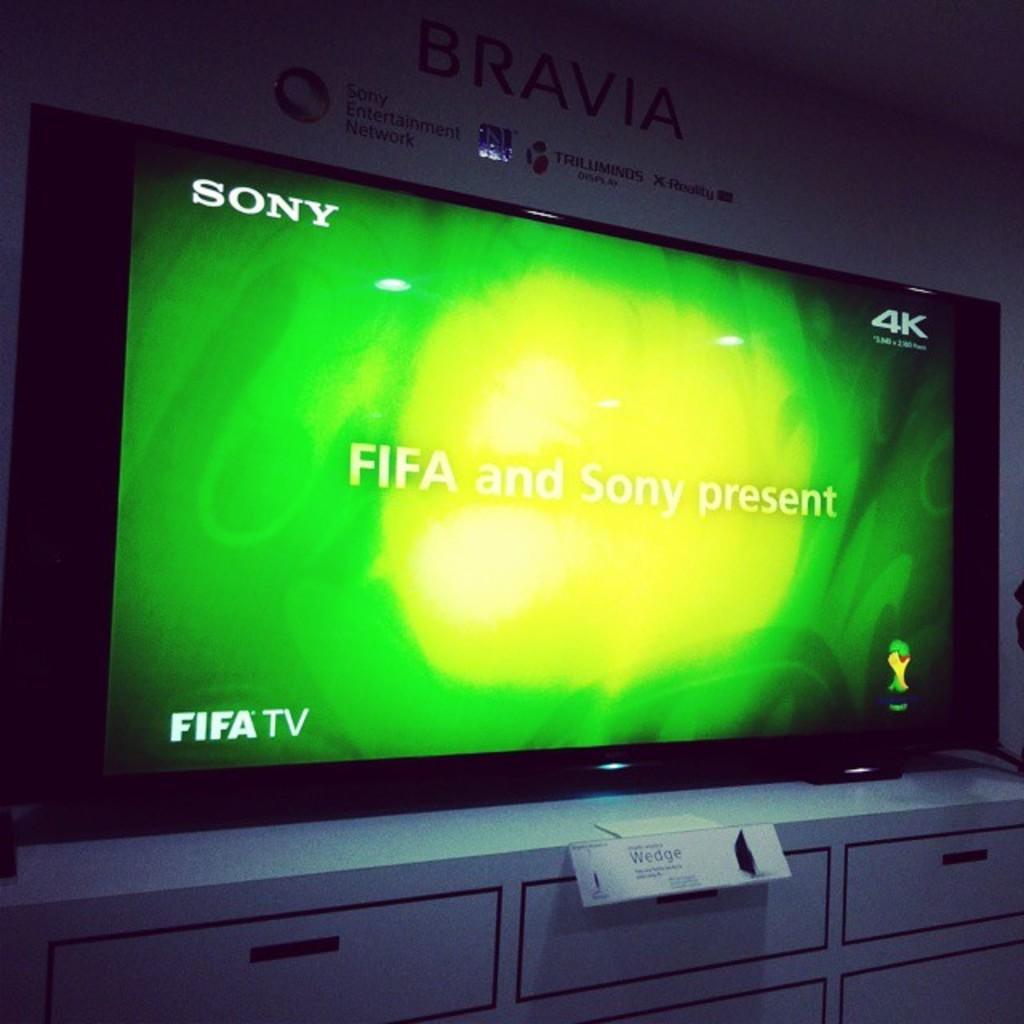What brand of tv is displayed on the screen?
Make the answer very short. Sony. Whats on the screen?
Ensure brevity in your answer.  Fifa and sony present. 